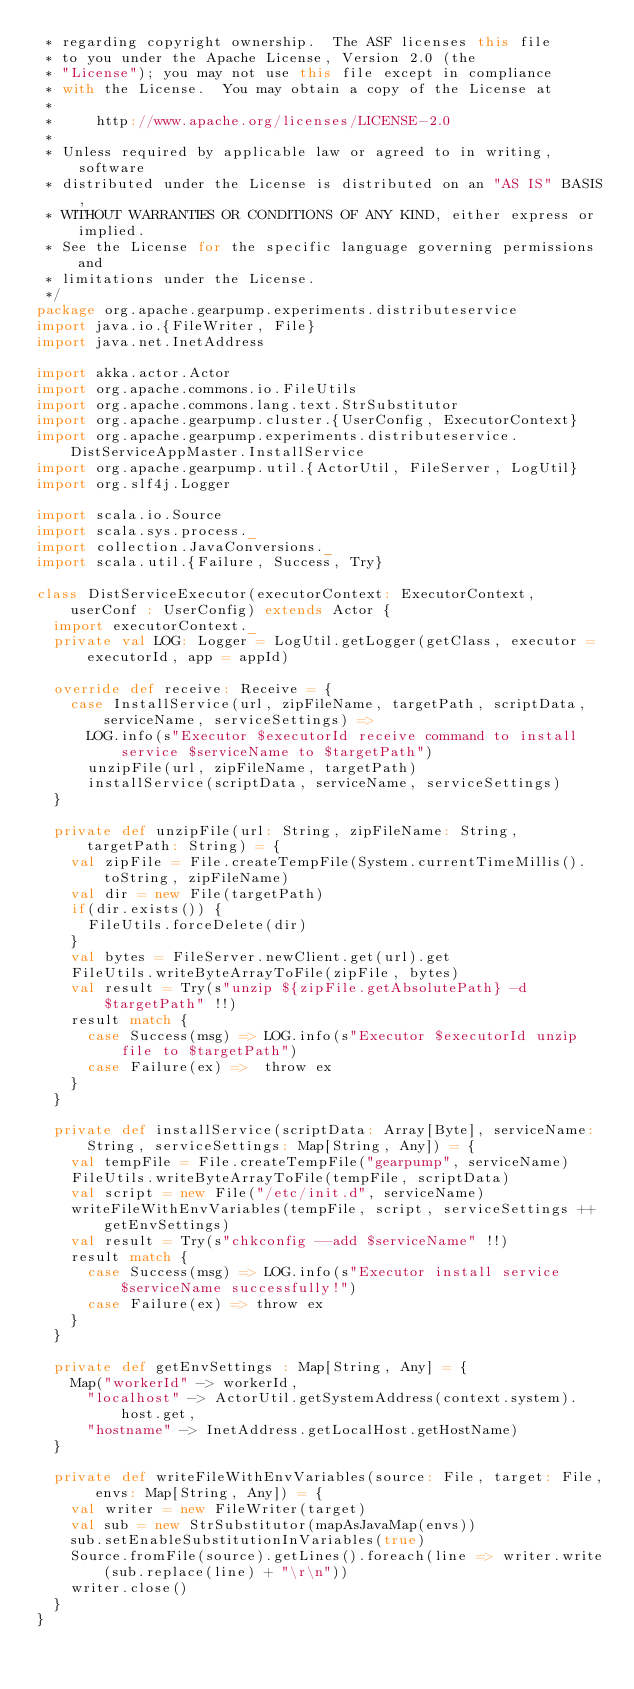Convert code to text. <code><loc_0><loc_0><loc_500><loc_500><_Scala_> * regarding copyright ownership.  The ASF licenses this file
 * to you under the Apache License, Version 2.0 (the
 * "License"); you may not use this file except in compliance
 * with the License.  You may obtain a copy of the License at
 *
 *     http://www.apache.org/licenses/LICENSE-2.0
 *
 * Unless required by applicable law or agreed to in writing, software
 * distributed under the License is distributed on an "AS IS" BASIS,
 * WITHOUT WARRANTIES OR CONDITIONS OF ANY KIND, either express or implied.
 * See the License for the specific language governing permissions and
 * limitations under the License.
 */
package org.apache.gearpump.experiments.distributeservice
import java.io.{FileWriter, File}
import java.net.InetAddress

import akka.actor.Actor
import org.apache.commons.io.FileUtils
import org.apache.commons.lang.text.StrSubstitutor
import org.apache.gearpump.cluster.{UserConfig, ExecutorContext}
import org.apache.gearpump.experiments.distributeservice.DistServiceAppMaster.InstallService
import org.apache.gearpump.util.{ActorUtil, FileServer, LogUtil}
import org.slf4j.Logger

import scala.io.Source
import scala.sys.process._
import collection.JavaConversions._
import scala.util.{Failure, Success, Try}

class DistServiceExecutor(executorContext: ExecutorContext, userConf : UserConfig) extends Actor {
  import executorContext._
  private val LOG: Logger = LogUtil.getLogger(getClass, executor = executorId, app = appId)

  override def receive: Receive = {
    case InstallService(url, zipFileName, targetPath, scriptData, serviceName, serviceSettings) =>
      LOG.info(s"Executor $executorId receive command to install service $serviceName to $targetPath")
      unzipFile(url, zipFileName, targetPath)
      installService(scriptData, serviceName, serviceSettings)
  }

  private def unzipFile(url: String, zipFileName: String, targetPath: String) = {
    val zipFile = File.createTempFile(System.currentTimeMillis().toString, zipFileName)
    val dir = new File(targetPath)
    if(dir.exists()) {
      FileUtils.forceDelete(dir)
    }
    val bytes = FileServer.newClient.get(url).get
    FileUtils.writeByteArrayToFile(zipFile, bytes)
    val result = Try(s"unzip ${zipFile.getAbsolutePath} -d $targetPath" !!)
    result match {
      case Success(msg) => LOG.info(s"Executor $executorId unzip file to $targetPath")
      case Failure(ex) =>  throw ex
    }
  }

  private def installService(scriptData: Array[Byte], serviceName: String, serviceSettings: Map[String, Any]) = {
    val tempFile = File.createTempFile("gearpump", serviceName)
    FileUtils.writeByteArrayToFile(tempFile, scriptData)
    val script = new File("/etc/init.d", serviceName)
    writeFileWithEnvVariables(tempFile, script, serviceSettings ++ getEnvSettings)
    val result = Try(s"chkconfig --add $serviceName" !!)
    result match {
      case Success(msg) => LOG.info(s"Executor install service $serviceName successfully!")
      case Failure(ex) => throw ex
    }
  }

  private def getEnvSettings : Map[String, Any] = {
    Map("workerId" -> workerId,
      "localhost" -> ActorUtil.getSystemAddress(context.system).host.get,
      "hostname" -> InetAddress.getLocalHost.getHostName)
  }

  private def writeFileWithEnvVariables(source: File, target: File, envs: Map[String, Any]) = {
    val writer = new FileWriter(target)
    val sub = new StrSubstitutor(mapAsJavaMap(envs))
    sub.setEnableSubstitutionInVariables(true)
    Source.fromFile(source).getLines().foreach(line => writer.write(sub.replace(line) + "\r\n"))
    writer.close()
  }
}
</code> 